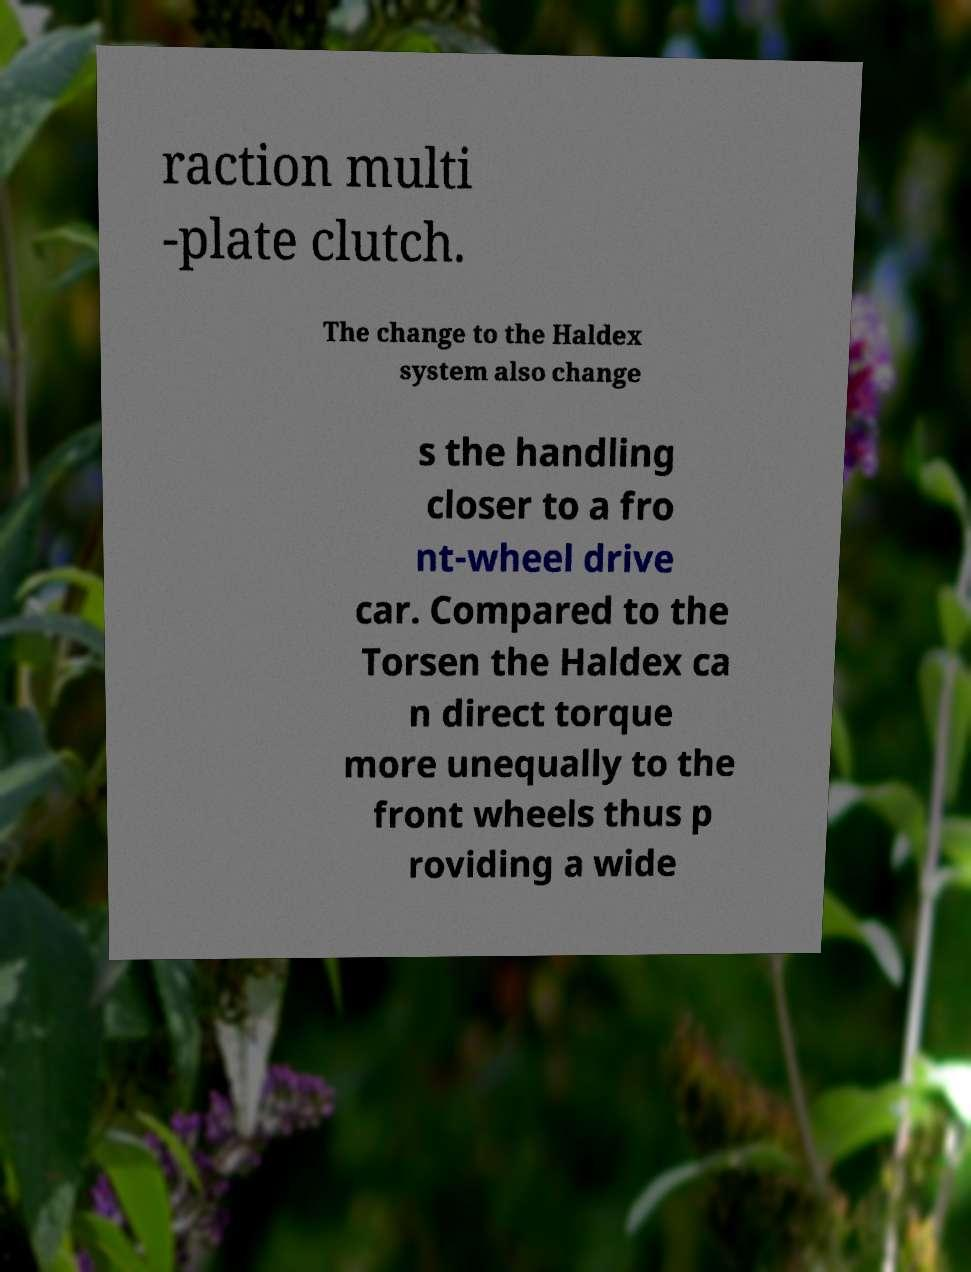What messages or text are displayed in this image? I need them in a readable, typed format. raction multi -plate clutch. The change to the Haldex system also change s the handling closer to a fro nt-wheel drive car. Compared to the Torsen the Haldex ca n direct torque more unequally to the front wheels thus p roviding a wide 